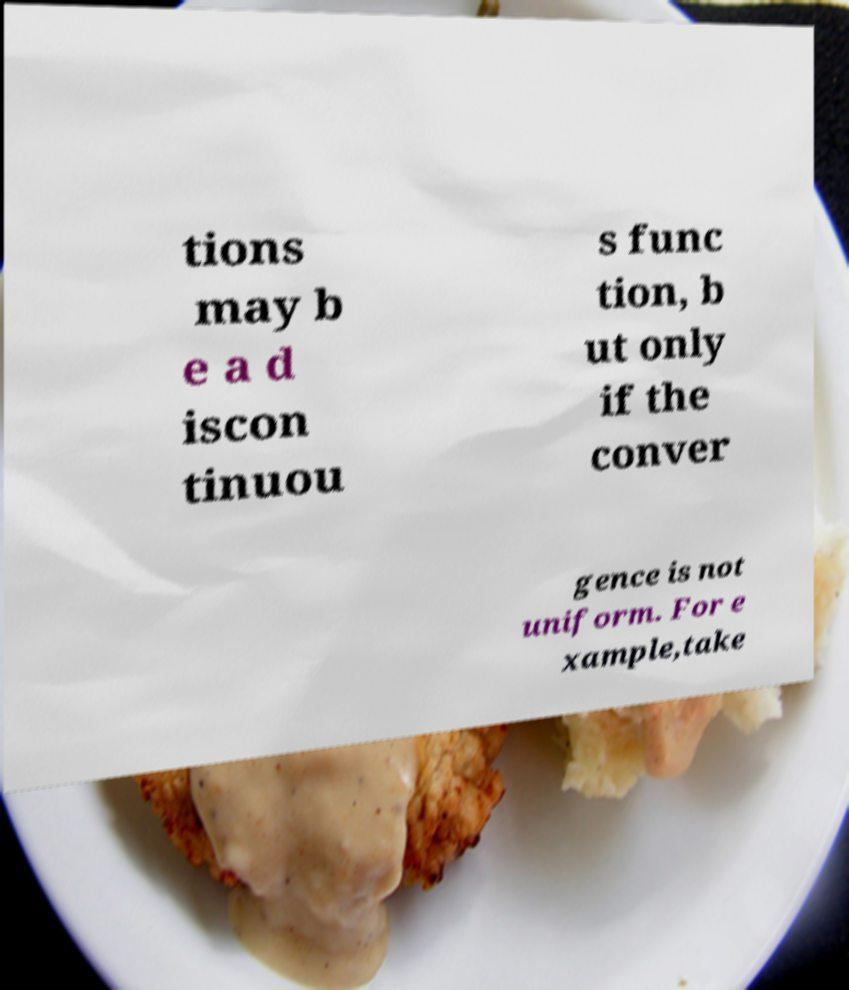Could you assist in decoding the text presented in this image and type it out clearly? tions may b e a d iscon tinuou s func tion, b ut only if the conver gence is not uniform. For e xample,take 